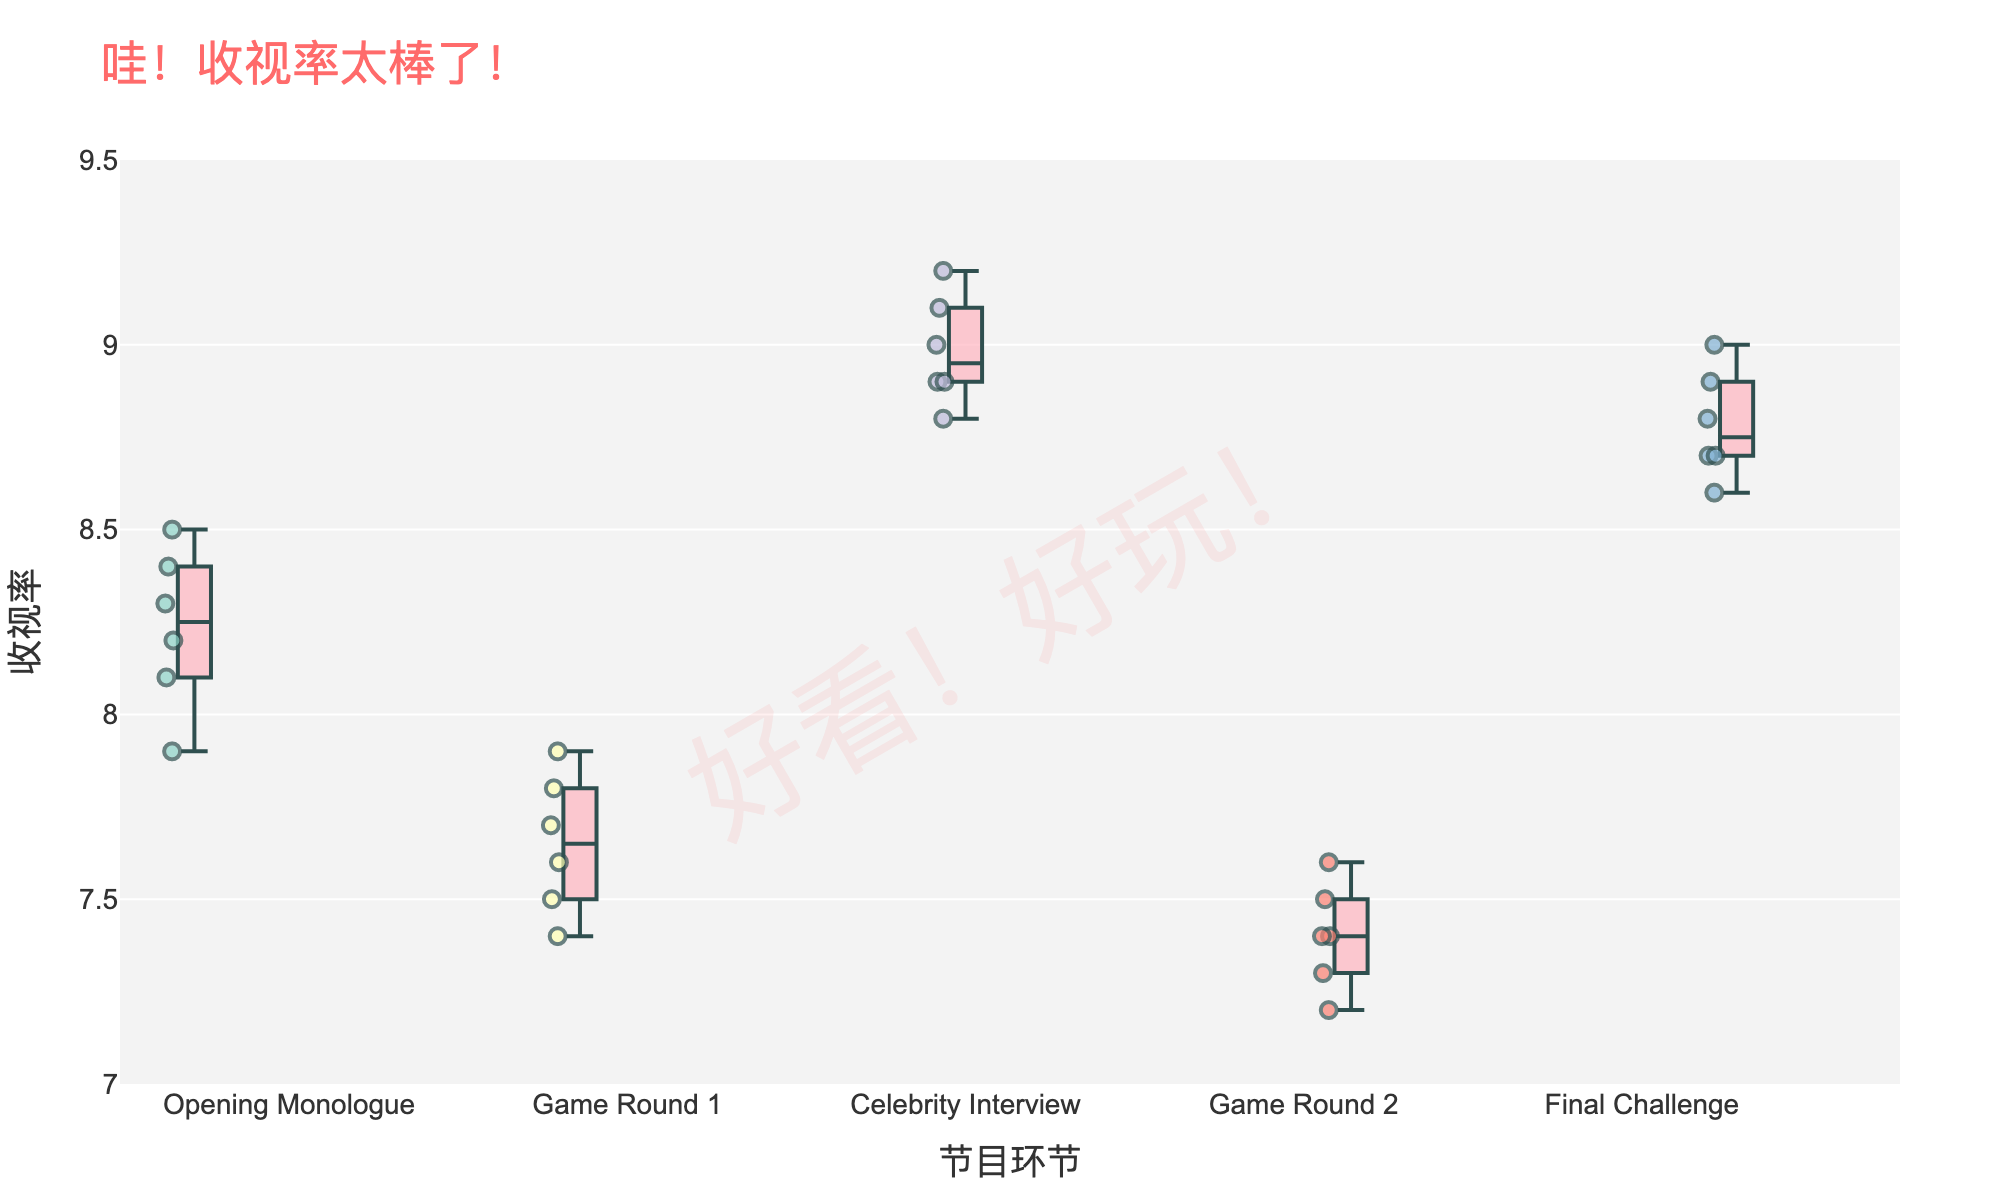How many segments are there in the plot? The plot shows five distinct boxes, each representing a different segment of the game show.
Answer: 5 Which segment has the highest median rating? The box of the 'Celebrity Interview' segment has its median line positioned the highest among all segments.
Answer: Celebrity Interview What is the range of ratings for the 'Final Challenge' segment? The 'Final Challenge' box stretches from the minimum value of around 8.6 to the maximum value of 9.0. The range is the difference between these values.
Answer: 0.4 Which segment has the smallest interquartile range (IQR)? IQR is calculated by subtracting the first quartile (Q1) from the third quartile (Q3). The 'Game Round 2' segment's box appears to be the most compressed, indicating the smallest IQR.
Answer: Game Round 2 Compare the variances in ratings between 'Opening Monologue' and 'Game Round 1'. Variance can be inferred from the spread of the box plots. 'Opening Monologue' has a wider spread and more outliers than 'Game Round 1', indicating a higher variance.
Answer: Opening Monologue has a higher variance Which segment has the lowest overall rating point and what is that rating? The whiskers of the 'Game Round 2' box plot extend to the lowest point among all segments; the lowest rating is around 7.2.
Answer: Game Round 2, 7.2 What's the median rating for the 'Final Challenge' segment? The median is represented by the line inside the box. For 'Final Challenge', the line appears around 8.75.
Answer: 8.75 How do the ratings of 'Celebrity Interview' compare in terms of outliers? The 'Celebrity Interview' box plot shows no points outside the whiskers, meaning there are no outliers in its ratings.
Answer: No outliers What is the highest rating given to any segment in the plot? The highest whisker value across all segments is in the 'Celebrity Interview' segment, reaching up to 9.2.
Answer: 9.2 